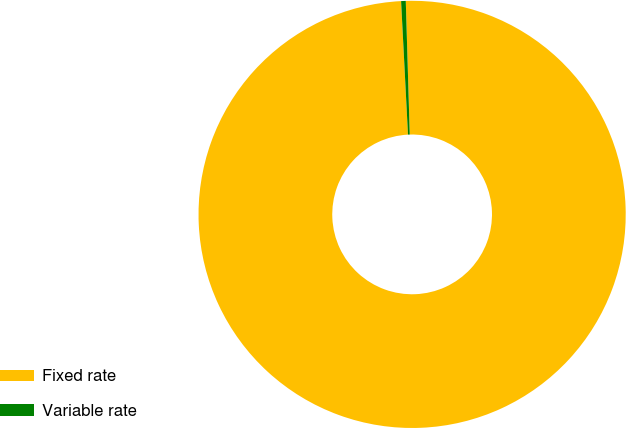Convert chart to OTSL. <chart><loc_0><loc_0><loc_500><loc_500><pie_chart><fcel>Fixed rate<fcel>Variable rate<nl><fcel>99.65%<fcel>0.35%<nl></chart> 